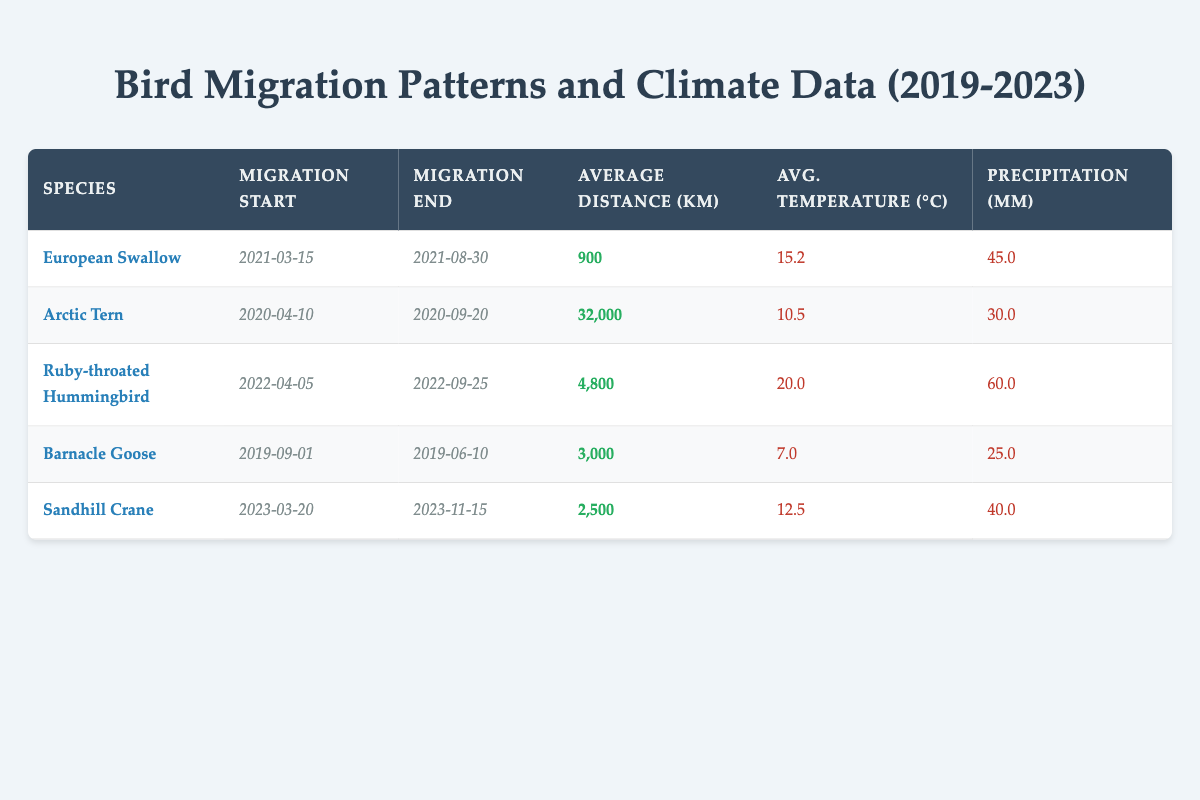What is the average distance migrated by the Barnacle Goose? The average distance migrated by the Barnacle Goose is displayed in the table under the "Average Distance (km)" column, which shows 3,000 km.
Answer: 3,000 km Which bird species migrated the farthest distance? To find the bird that migrated the farthest, I reviewed the "Average Distance (km)" column and identified that the Arctic Tern has the highest value at 32,000 km.
Answer: Arctic Tern Did the European Swallow migrate in a warmer climate than the Sandhill Crane? Comparing the "Avg. Temperature (°C)" for both species, the European Swallow has an average temperature of 15.2°C and the Sandhill Crane has 12.5°C. Since 15.2°C is greater than 12.5°C, the statement is true.
Answer: Yes How many species migrated with an average temperature above 15°C? By examining the "Avg. Temperature (°C)" column, I found that two species had values above 15°C: the Ruby-throated Hummingbird (20.0°C) and the European Swallow (15.2°C). Therefore, the total is 2.
Answer: 2 What is the total precipitation for all the species listed in the table? I will sum the values in the "Precipitation (mm)" column: 45.0 + 30.0 + 60.0 + 25.0 + 40.0 = 200. Thus, the total precipitation recorded is 200 mm.
Answer: 200 mm What is the ratio of migration distance of the Arctic Tern to the Ruby-throated Hummingbird? The migration distance for the Arctic Tern is 32,000 km, and for the Ruby-throated Hummingbird, it is 4,800 km. The ratio is calculated as 32,000 / 4,800, which simplifies to \( \frac{32000}{4800} = \frac{20}{3} \) or approximately 6.67.
Answer: 6.67 Which bird species had the earliest migration start date? Reviewing the "Migration Start" column, I found that the Barnacle Goose started migrating on September 1, 2019, which is the earliest date compared to the others listed.
Answer: Barnacle Goose Is the average migration end date for the Sandhill Crane later than for the Arctic Tern? The migration end date for the Sandhill Crane is November 15, 2023, and for the Arctic Tern it is September 20, 2020. Since November 15, 2023, is later than September 20, 2020, the statement is true.
Answer: Yes 